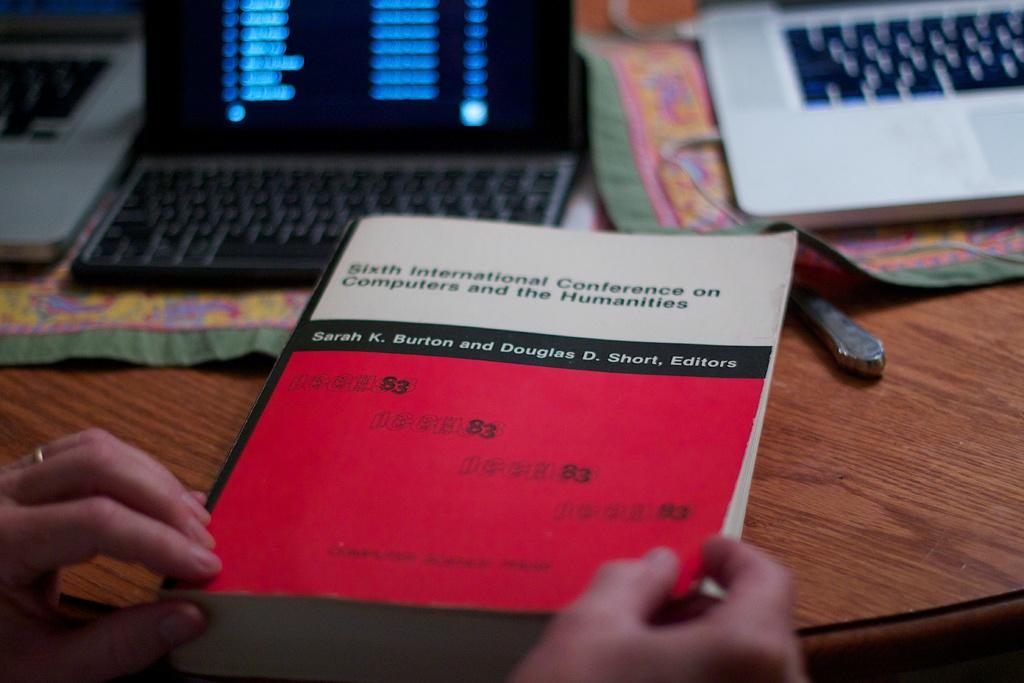What is the first letter of the first word on the black stripe on the book?
Keep it short and to the point. S. 